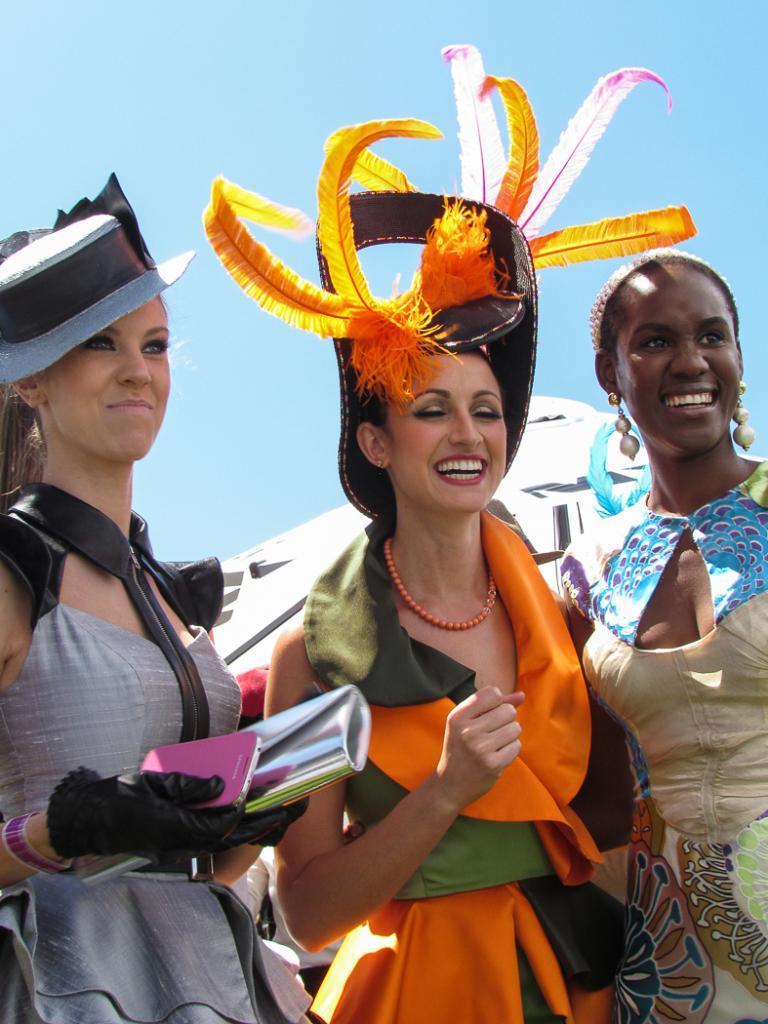How would you summarize this image in a sentence or two? In this image, we can see three women standing and they are smiling, at the top we can see the blue sky. 